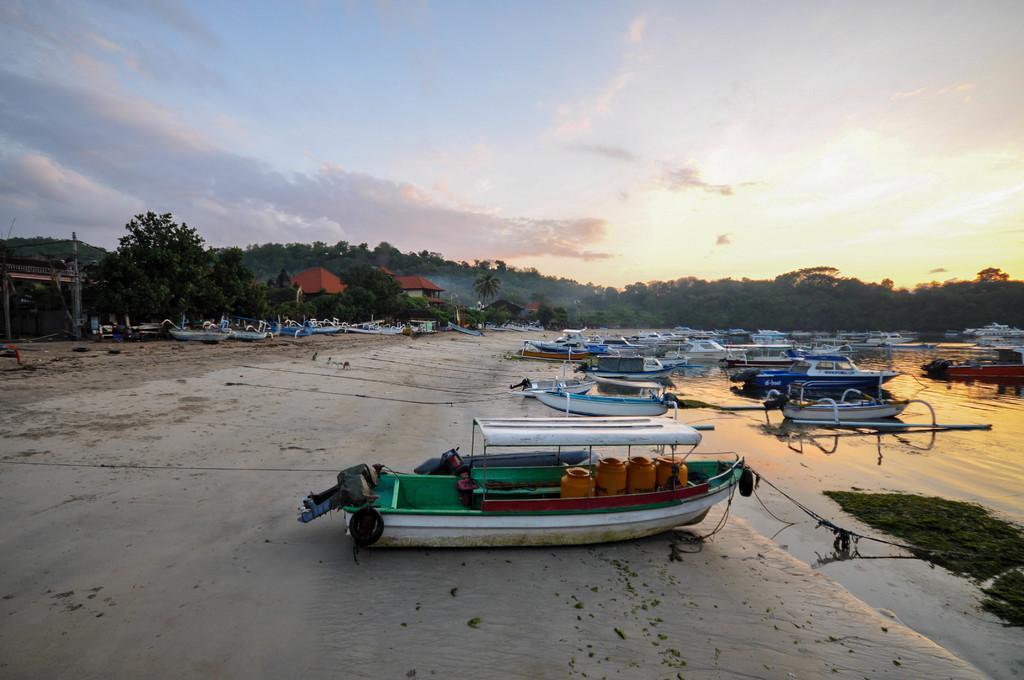Describe this image in one or two sentences. In the image we can see there are many boats in the water. Here we can see there are trees, hills and cloudy sky. We can even see the ropes and there are contained in the boat. 